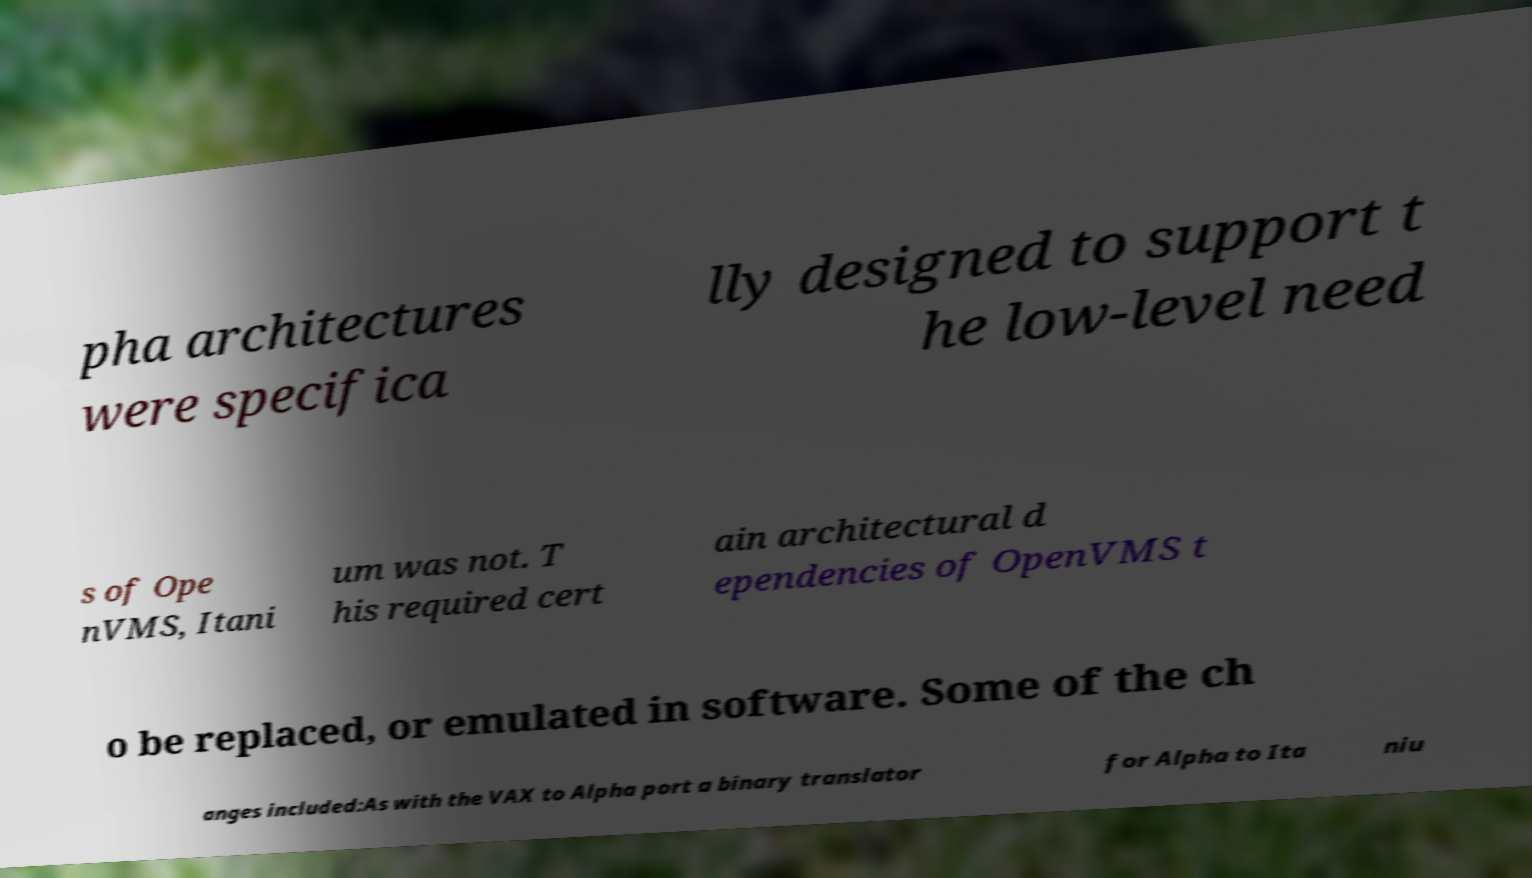Please identify and transcribe the text found in this image. pha architectures were specifica lly designed to support t he low-level need s of Ope nVMS, Itani um was not. T his required cert ain architectural d ependencies of OpenVMS t o be replaced, or emulated in software. Some of the ch anges included:As with the VAX to Alpha port a binary translator for Alpha to Ita niu 